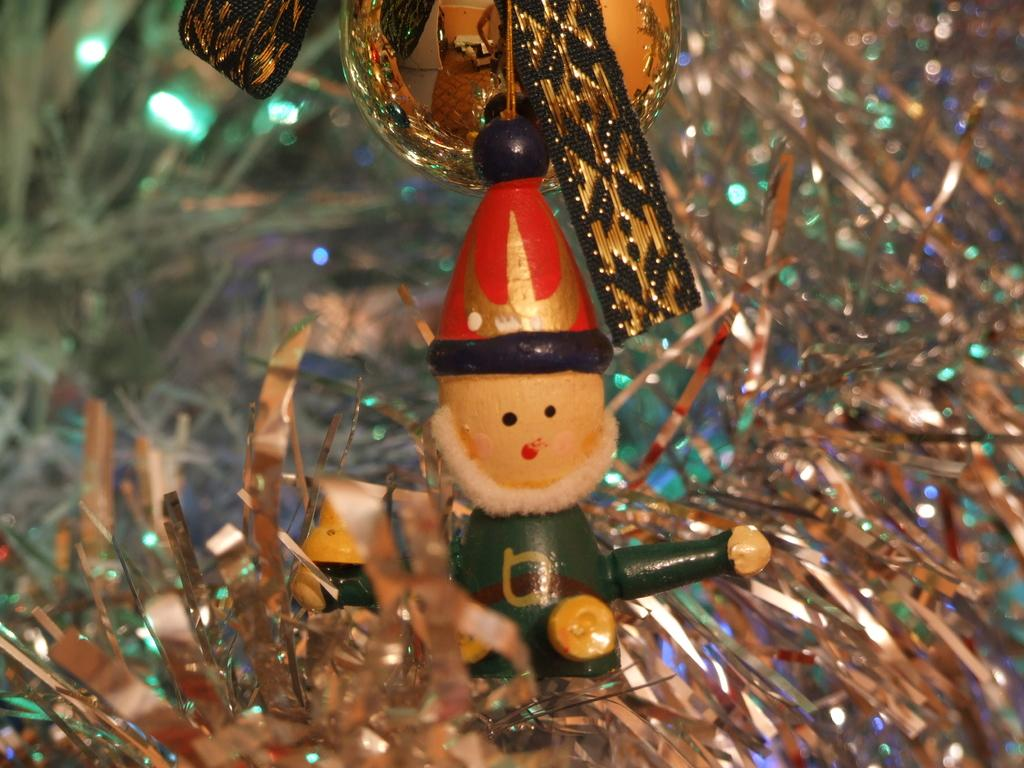What is the purpose of the image? The image is a decoration. What figure can be seen in the decoration? There is a Santa Claus doll in the decoration. What type of cave is depicted in the decoration? There is no cave present in the decoration; it features a Santa Claus doll. What discovery is being made by the Santa Claus doll in the decoration? The Santa Claus doll is not making any discoveries in the decoration; it is a static figure. 